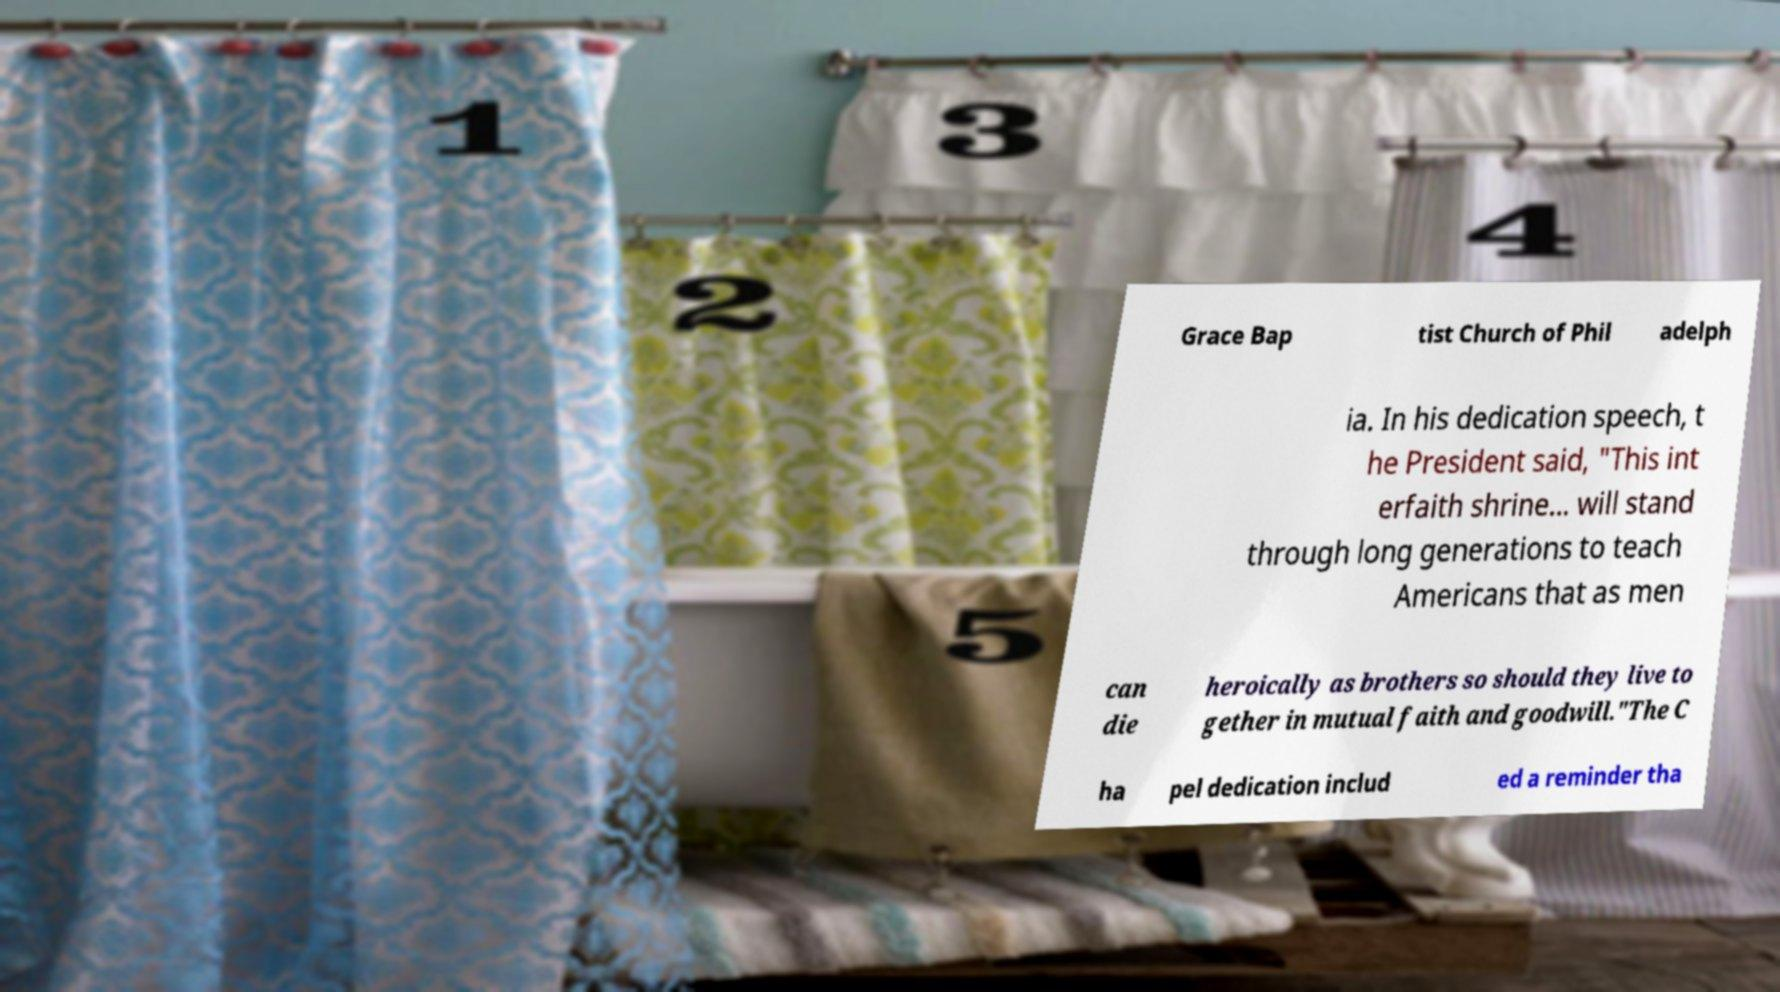Could you assist in decoding the text presented in this image and type it out clearly? Grace Bap tist Church of Phil adelph ia. In his dedication speech, t he President said, "This int erfaith shrine... will stand through long generations to teach Americans that as men can die heroically as brothers so should they live to gether in mutual faith and goodwill."The C ha pel dedication includ ed a reminder tha 